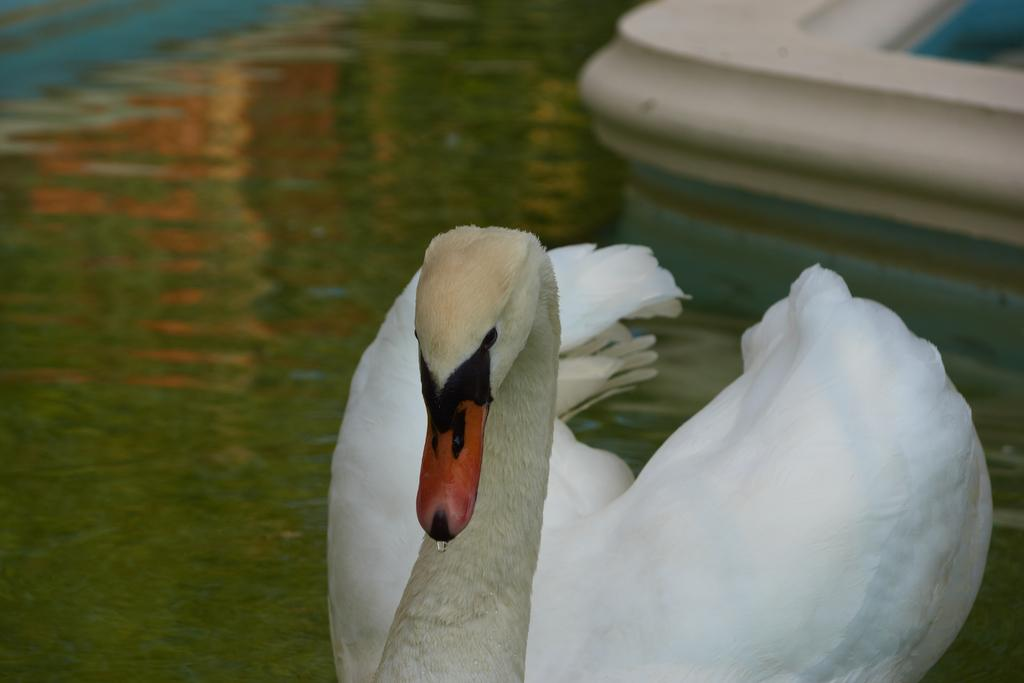What animal is the main subject of the image? There is a swan in the image. Where is the swan located in the image? The swan is in the front of the image. What type of environment is visible in the image? There is water visible at the bottom of the image. What type of jeans is the duck wearing in the image? There is no duck or jeans present in the image; it features a swan in a watery environment. 